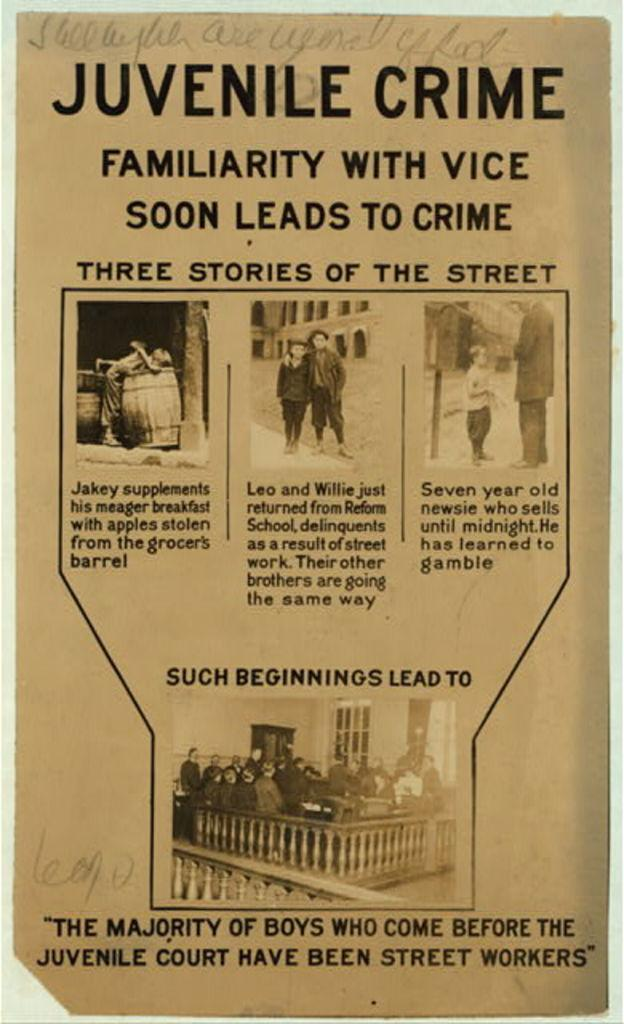What is the main subject of the image? The main subject of the image is a page. What can be found on the page? There is text and pictures on the page. What type of adjustment can be seen being made to the texture of the noise in the image? There is no adjustment, texture, or noise present in the image; it features a page with text and pictures. 